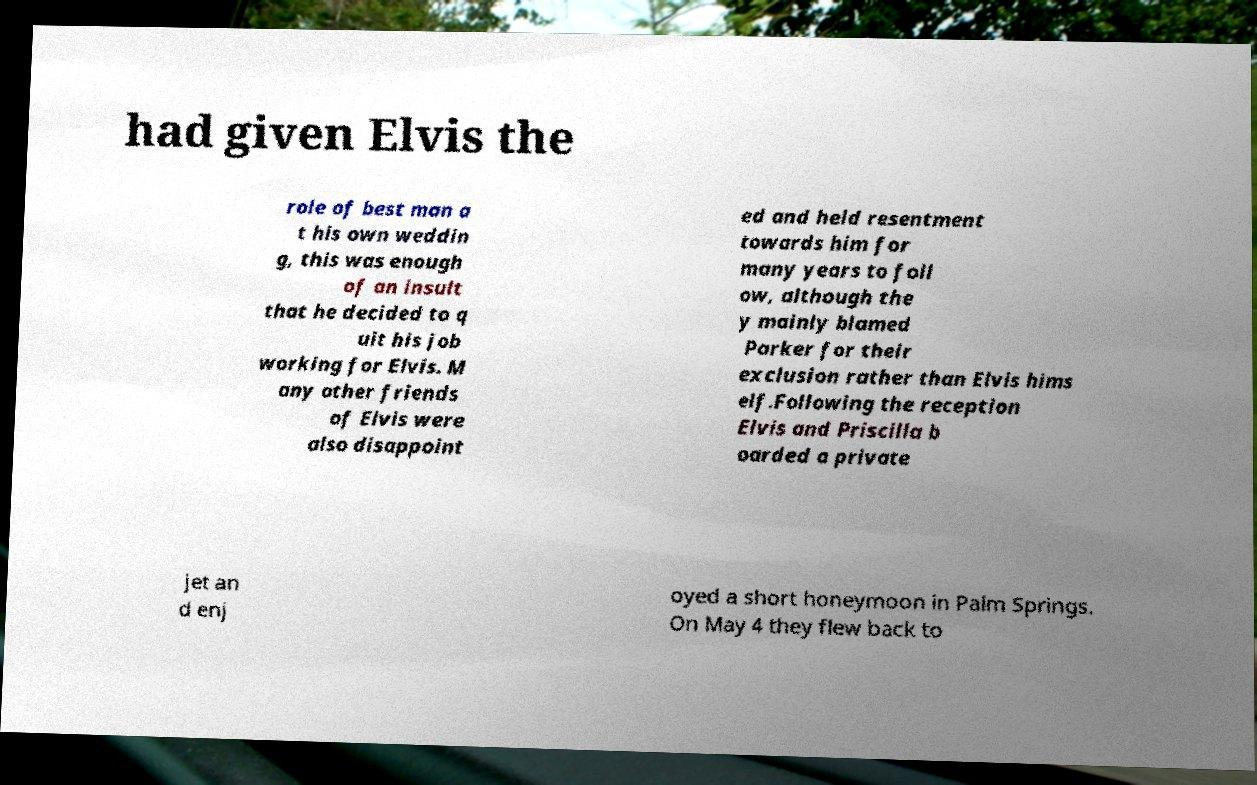For documentation purposes, I need the text within this image transcribed. Could you provide that? had given Elvis the role of best man a t his own weddin g, this was enough of an insult that he decided to q uit his job working for Elvis. M any other friends of Elvis were also disappoint ed and held resentment towards him for many years to foll ow, although the y mainly blamed Parker for their exclusion rather than Elvis hims elf.Following the reception Elvis and Priscilla b oarded a private jet an d enj oyed a short honeymoon in Palm Springs. On May 4 they flew back to 